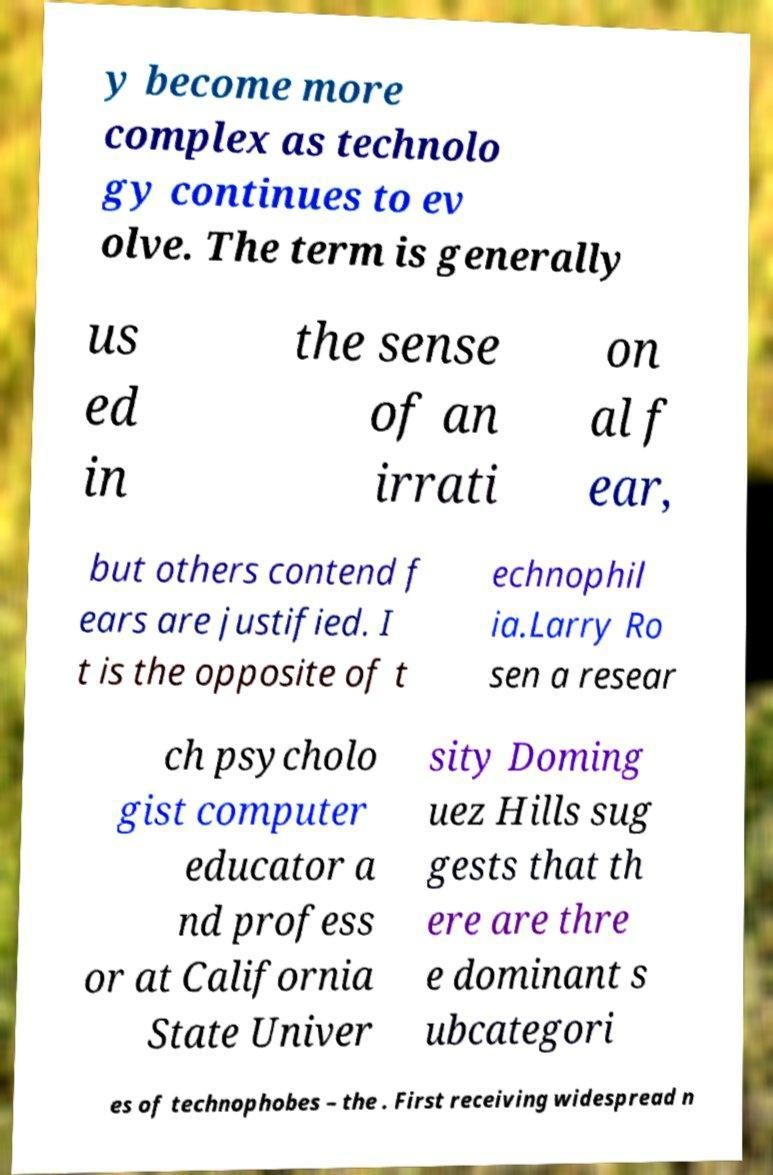Can you read and provide the text displayed in the image?This photo seems to have some interesting text. Can you extract and type it out for me? y become more complex as technolo gy continues to ev olve. The term is generally us ed in the sense of an irrati on al f ear, but others contend f ears are justified. I t is the opposite of t echnophil ia.Larry Ro sen a resear ch psycholo gist computer educator a nd profess or at California State Univer sity Doming uez Hills sug gests that th ere are thre e dominant s ubcategori es of technophobes – the . First receiving widespread n 